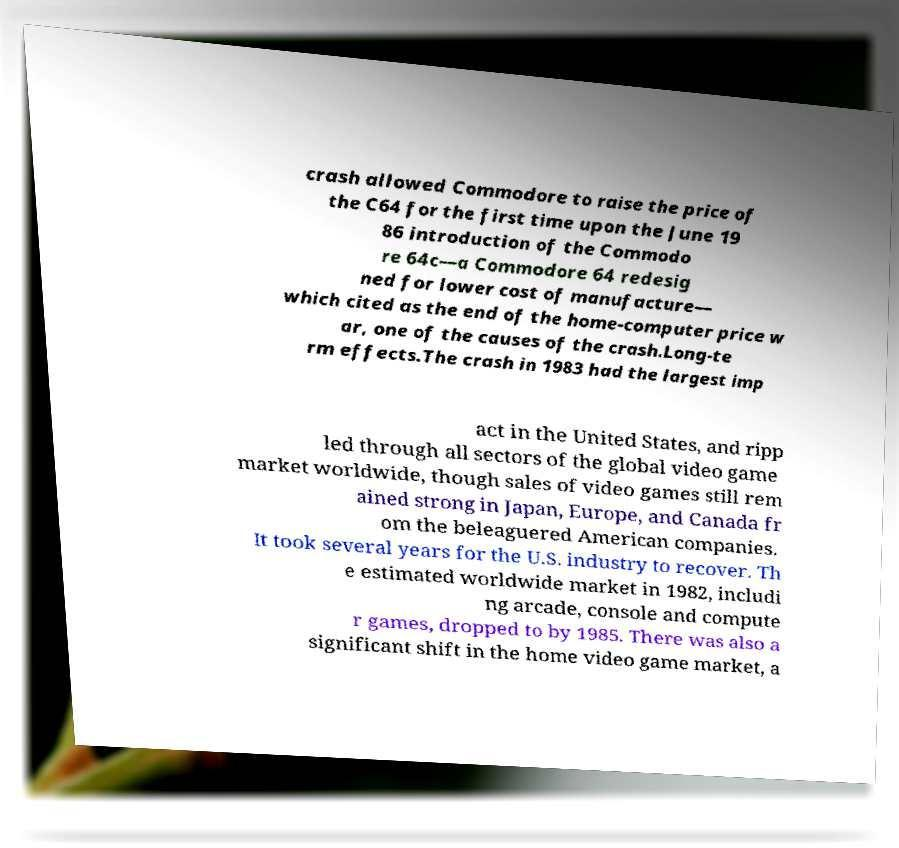Can you accurately transcribe the text from the provided image for me? crash allowed Commodore to raise the price of the C64 for the first time upon the June 19 86 introduction of the Commodo re 64c—a Commodore 64 redesig ned for lower cost of manufacture— which cited as the end of the home-computer price w ar, one of the causes of the crash.Long-te rm effects.The crash in 1983 had the largest imp act in the United States, and ripp led through all sectors of the global video game market worldwide, though sales of video games still rem ained strong in Japan, Europe, and Canada fr om the beleaguered American companies. It took several years for the U.S. industry to recover. Th e estimated worldwide market in 1982, includi ng arcade, console and compute r games, dropped to by 1985. There was also a significant shift in the home video game market, a 